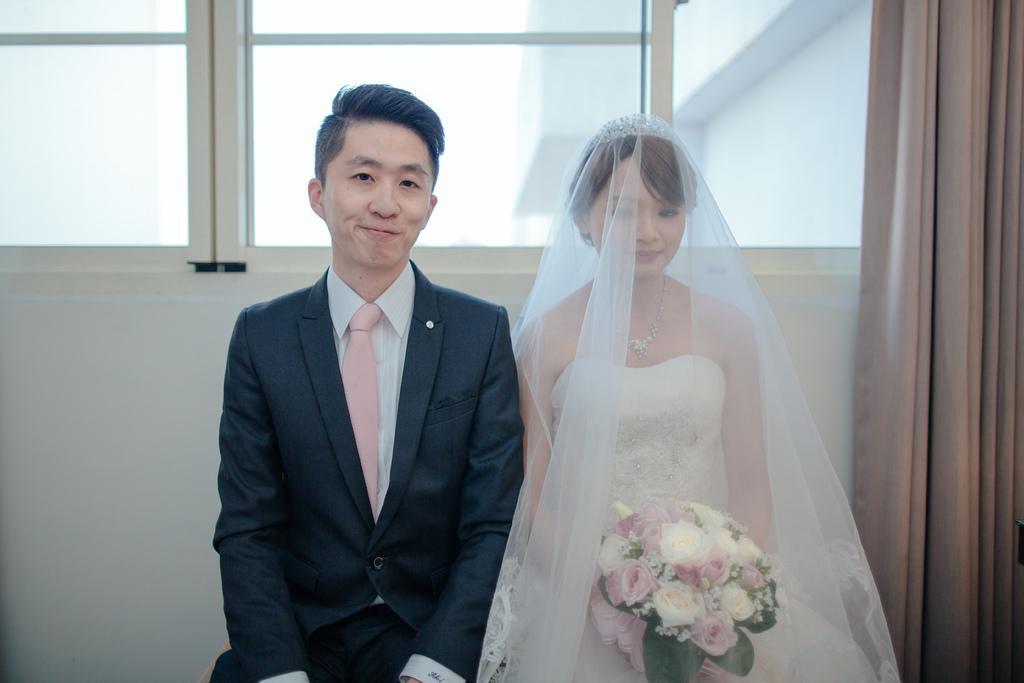Can you describe this image briefly? In the middle of the image two persons are standing, smiling and she is holding a flower bouquet. Behind them we can see a wall, windows and curtain. 